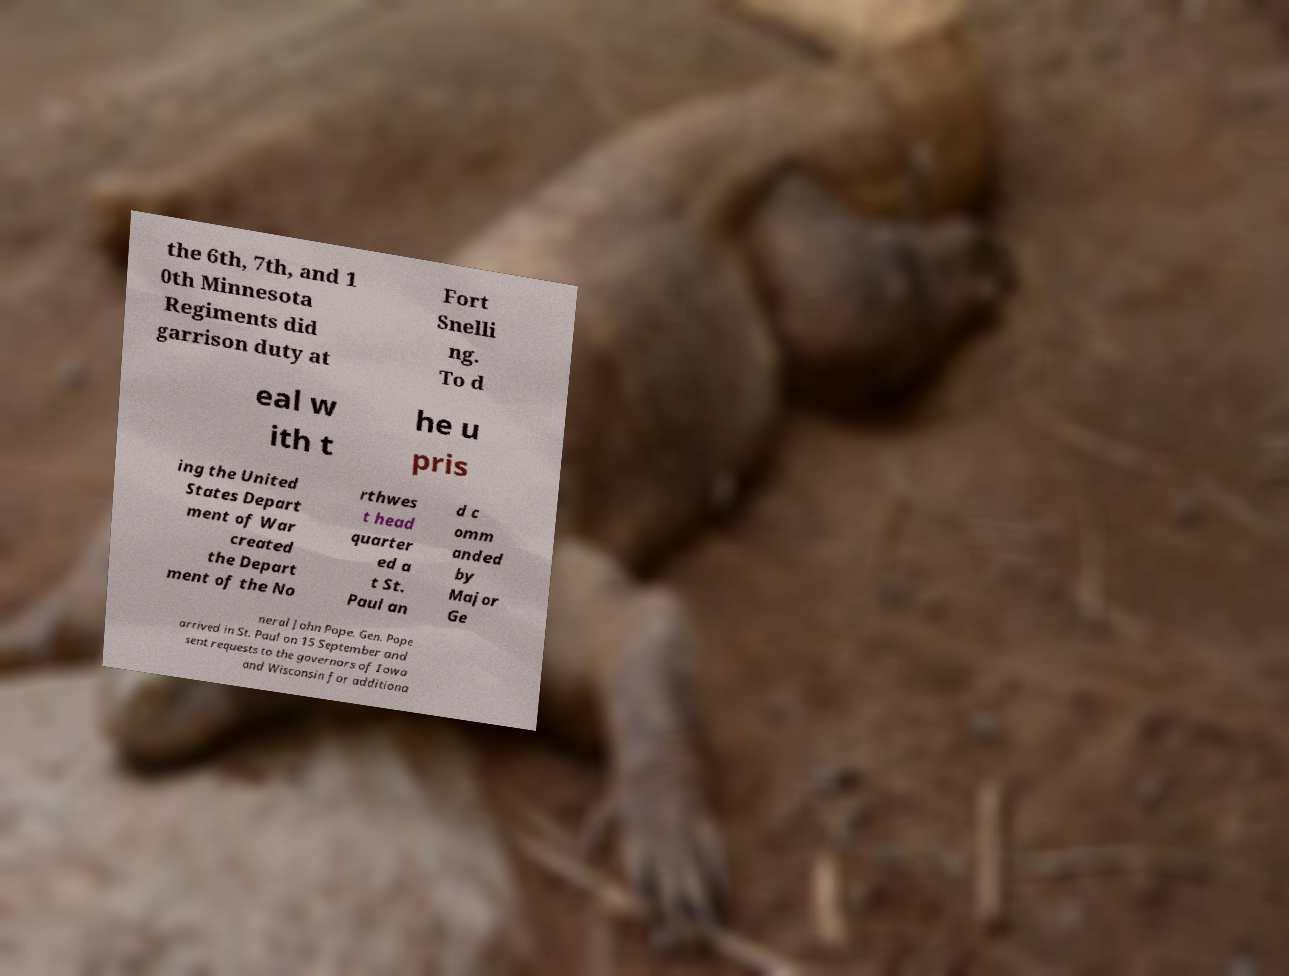I need the written content from this picture converted into text. Can you do that? the 6th, 7th, and 1 0th Minnesota Regiments did garrison duty at Fort Snelli ng. To d eal w ith t he u pris ing the United States Depart ment of War created the Depart ment of the No rthwes t head quarter ed a t St. Paul an d c omm anded by Major Ge neral John Pope. Gen. Pope arrived in St. Paul on 15 September and sent requests to the governors of Iowa and Wisconsin for additiona 